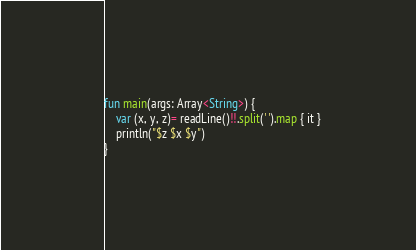<code> <loc_0><loc_0><loc_500><loc_500><_Kotlin_>fun main(args: Array<String>) {
    var (x, y, z)= readLine()!!.split(' ').map { it }
    println("$z $x $y")
}</code> 